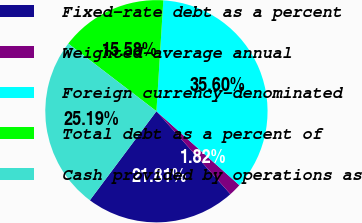Convert chart to OTSL. <chart><loc_0><loc_0><loc_500><loc_500><pie_chart><fcel>Fixed-rate debt as a percent<fcel>Weighted-average annual<fcel>Foreign currency-denominated<fcel>Total debt as a percent of<fcel>Cash provided by operations as<nl><fcel>21.81%<fcel>1.82%<fcel>35.6%<fcel>15.58%<fcel>25.19%<nl></chart> 